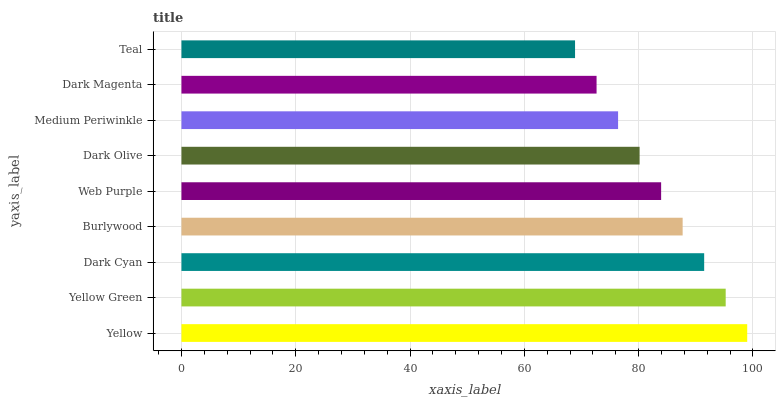Is Teal the minimum?
Answer yes or no. Yes. Is Yellow the maximum?
Answer yes or no. Yes. Is Yellow Green the minimum?
Answer yes or no. No. Is Yellow Green the maximum?
Answer yes or no. No. Is Yellow greater than Yellow Green?
Answer yes or no. Yes. Is Yellow Green less than Yellow?
Answer yes or no. Yes. Is Yellow Green greater than Yellow?
Answer yes or no. No. Is Yellow less than Yellow Green?
Answer yes or no. No. Is Web Purple the high median?
Answer yes or no. Yes. Is Web Purple the low median?
Answer yes or no. Yes. Is Medium Periwinkle the high median?
Answer yes or no. No. Is Dark Olive the low median?
Answer yes or no. No. 